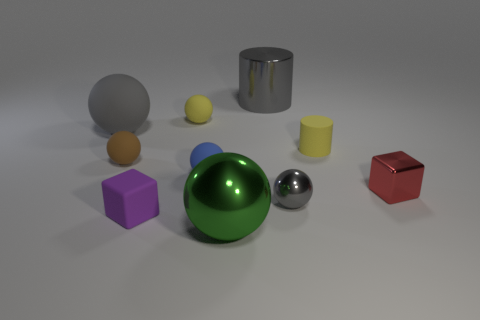There is a purple rubber object; what shape is it?
Give a very brief answer. Cube. How big is the gray ball that is behind the block to the right of the blue matte thing?
Your answer should be very brief. Large. Is the number of large spheres in front of the yellow matte cylinder the same as the number of green metallic balls that are behind the red cube?
Keep it short and to the point. No. What material is the sphere that is both in front of the yellow cylinder and on the left side of the small purple matte cube?
Your answer should be very brief. Rubber. Is the size of the blue rubber sphere the same as the cylinder that is behind the large gray matte sphere?
Give a very brief answer. No. How many other things are there of the same color as the tiny metal ball?
Your response must be concise. 2. Are there more small cubes to the right of the small purple rubber object than large purple things?
Give a very brief answer. Yes. The rubber object behind the large ball that is behind the gray ball that is in front of the large gray matte ball is what color?
Offer a very short reply. Yellow. Is the material of the big gray ball the same as the green thing?
Ensure brevity in your answer.  No. Are there any yellow balls of the same size as the blue ball?
Your answer should be very brief. Yes. 